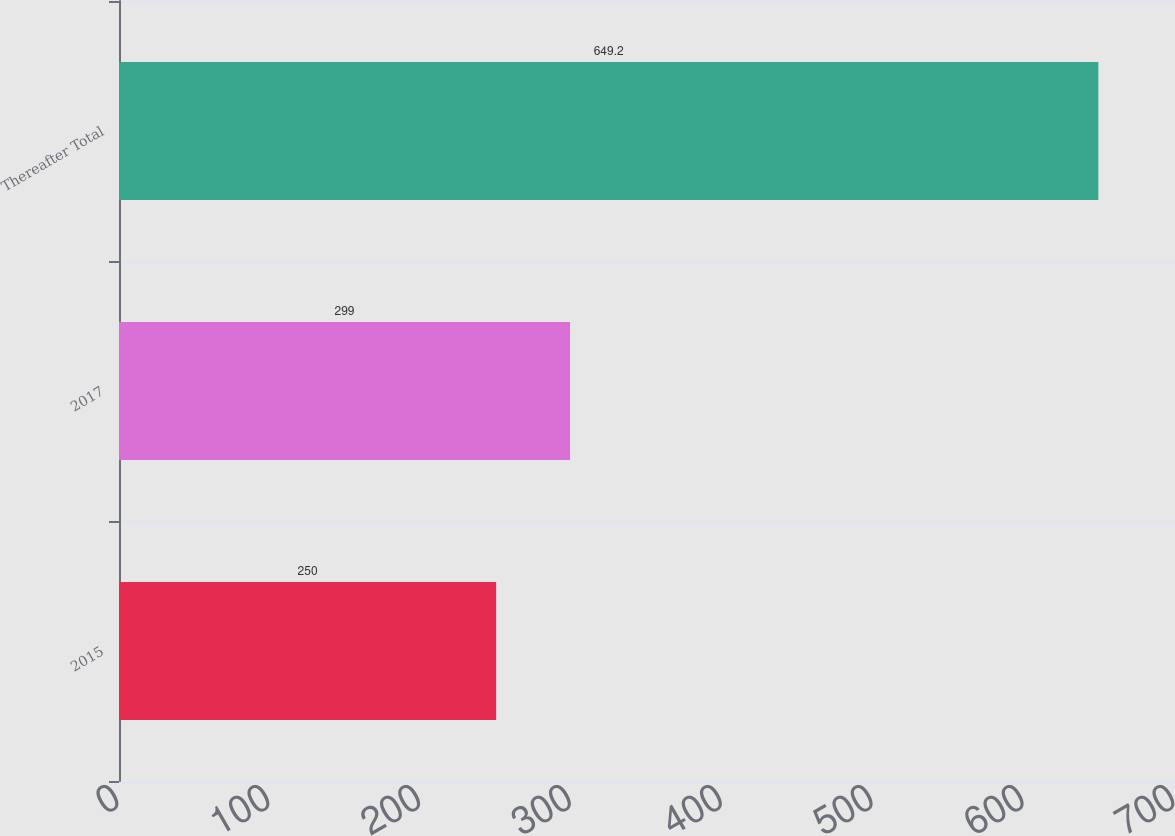Convert chart to OTSL. <chart><loc_0><loc_0><loc_500><loc_500><bar_chart><fcel>2015<fcel>2017<fcel>Thereafter Total<nl><fcel>250<fcel>299<fcel>649.2<nl></chart> 